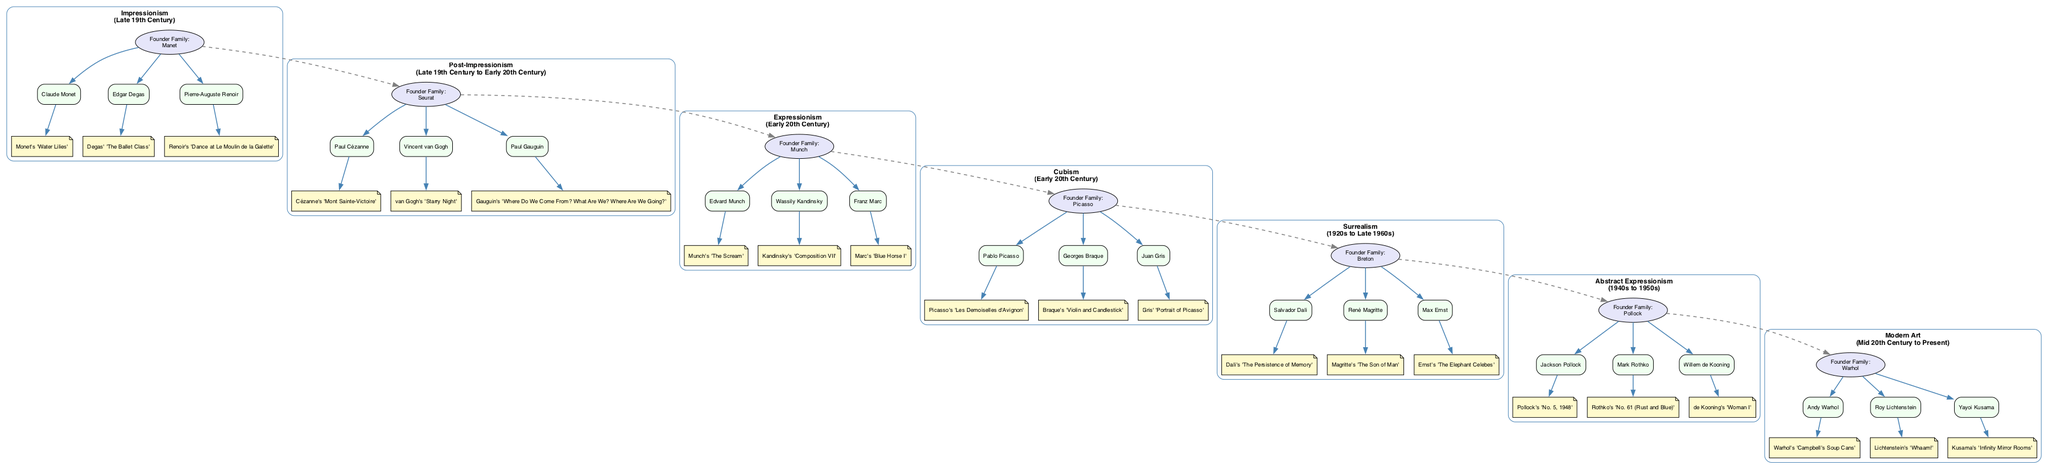What family is associated with Impressionism? According to the diagram, the founder family for Impressionism is Manet. This is stated directly under the Impressionism node.
Answer: Manet How many key figures are there in Cubism? The Cubism section of the diagram lists three key figures: Pablo Picasso, Georges Braque, and Juan Gris. This can be counted directly from the key figures nodes connected to the Cubism founder.
Answer: 3 Which prominent work is created by Vincent van Gogh? In the Post-Impressionism section, among the prominent works, "Starry Night" is listed and categorized under van Gogh's name. We can find this connection in the respective nodes.
Answer: Starry Night What art movement comes after Expressionism? Looking at the chronological connections shown with dashed edges, Cubism follows Expressionism in the progression of the art movements depicted in the diagram.
Answer: Cubism Which art movement was founded by the family Pollock? The diagram indicates that the founder family for Abstract Expressionism is Pollock, which is specified directly within the Abstract Expressionism section.
Answer: Abstract Expressionism What are the prominent works under Surrealism? Under the Surrealism section, the prominent works include "The Persistence of Memory" by Dalí, "The Son of Man" by Magritte, and "The Elephant Celebes" by Ernst. These can be found under the works nodes connected to their respective key figures.
Answer: The Persistence of Memory, The Son of Man, The Elephant Celebes Which two families connect the art movements of Post-Impressionism and Expressionism? The founder family of Post-Impressionism is Seurat, and the founder family of Expressionism is Munch. These two families are connected through a dashed edge symbolizing the chronological progression from Post-Impressionism to Expressionism in the diagram.
Answer: Seurat, Munch What is the period for Modern Art? The period indicated for Modern Art in the diagram is "Mid 20th Century to Present". This is mentioned directly below the Modern Art node.
Answer: Mid 20th Century to Present Which key figure is associated with Abstract Expressionism? The diagram lists Jackson Pollock as one of the key figures of Abstract Expressionism. This can be identified in the respective nodes for Abstract Expressionism.
Answer: Jackson Pollock 